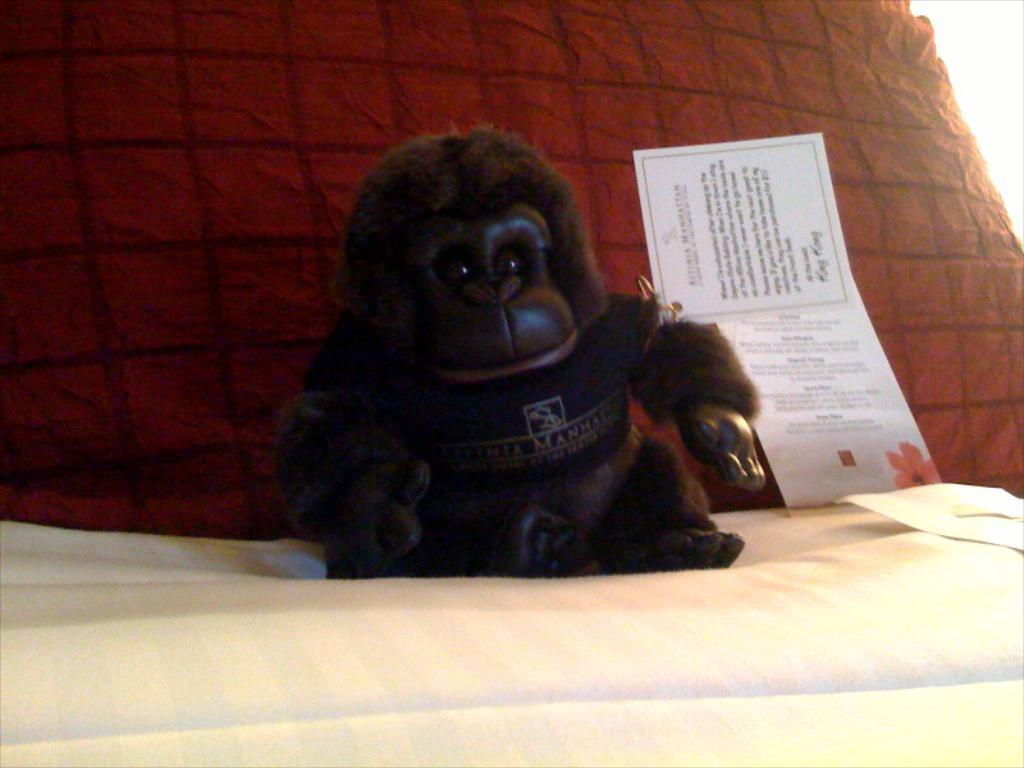What object can be seen in the image that is meant for play? There is a toy in the image. What type of items are placed on the cloth in the image? There are cards and a toy placed on the cloth. What is the color of the pillow in the background of the image? The pillow in the background of the image is red. How does the kitten behave when it sees the toy in the image? There is no kitten present in the image, so its behavior cannot be observed. 